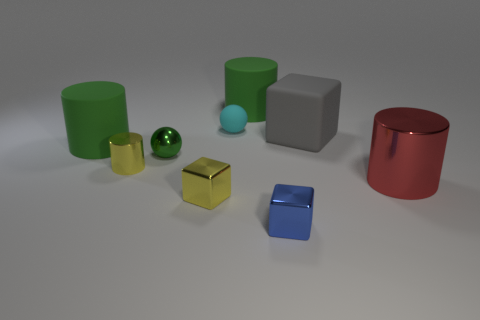Is the color of the matte sphere the same as the metal cylinder that is on the left side of the small blue cube?
Offer a very short reply. No. How many other objects are the same material as the cyan sphere?
Give a very brief answer. 3. The green object that is the same material as the small yellow cylinder is what shape?
Give a very brief answer. Sphere. Is there any other thing of the same color as the big block?
Keep it short and to the point. No. What is the size of the object that is the same color as the small cylinder?
Provide a succinct answer. Small. Are there more large blocks that are on the right side of the gray thing than small blue metal objects?
Keep it short and to the point. No. There is a red metallic thing; is it the same shape as the green thing that is behind the large gray matte cube?
Keep it short and to the point. Yes. What number of metal spheres are the same size as the red thing?
Provide a short and direct response. 0. There is a big rubber cylinder to the right of the thing that is left of the tiny cylinder; what number of yellow metal cylinders are behind it?
Keep it short and to the point. 0. Are there the same number of small yellow shiny cylinders that are on the right side of the blue metal cube and big metal cylinders that are in front of the red object?
Provide a short and direct response. Yes. 